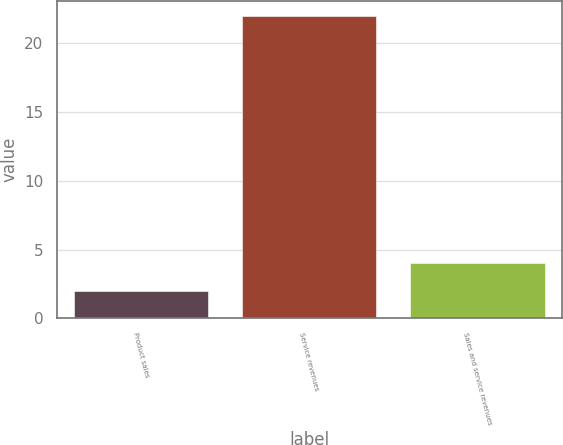Convert chart. <chart><loc_0><loc_0><loc_500><loc_500><bar_chart><fcel>Product sales<fcel>Service revenues<fcel>Sales and service revenues<nl><fcel>2<fcel>22<fcel>4<nl></chart> 